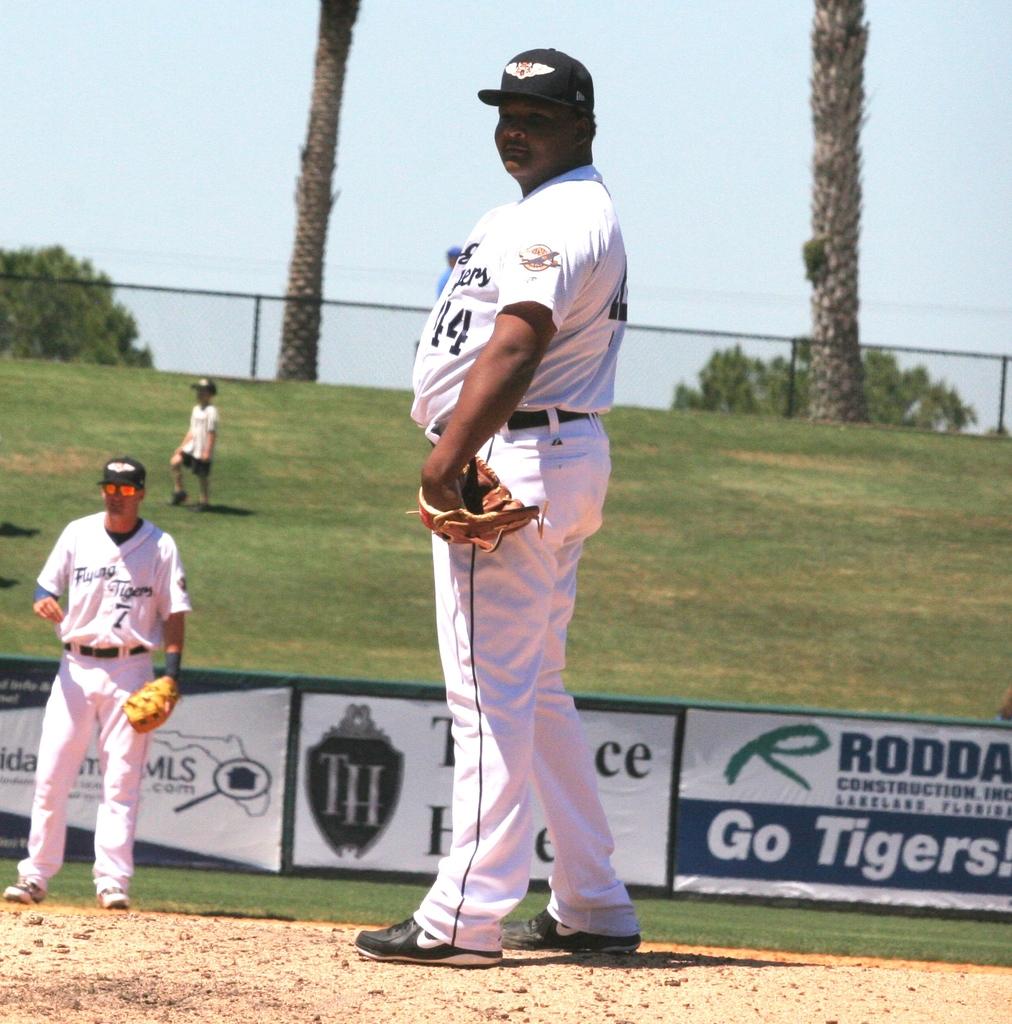Who is being cheered on my the sign in the backgroun?
Provide a short and direct response. Tigers. 